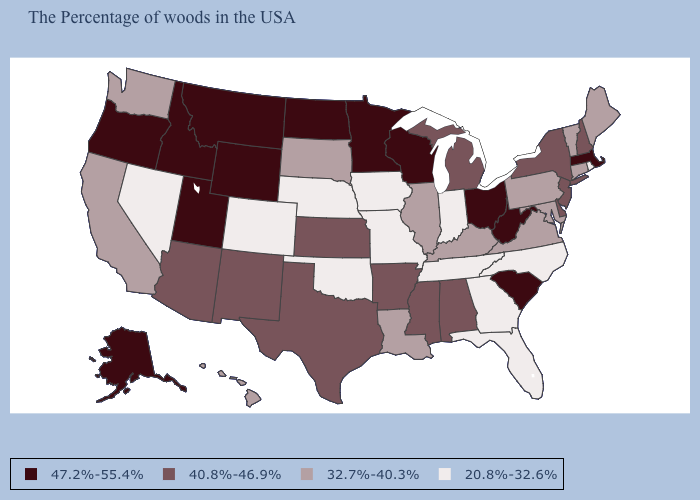Among the states that border Connecticut , does New York have the highest value?
Answer briefly. No. What is the lowest value in the West?
Answer briefly. 20.8%-32.6%. What is the value of Oregon?
Write a very short answer. 47.2%-55.4%. Among the states that border Virginia , which have the lowest value?
Be succinct. North Carolina, Tennessee. What is the lowest value in states that border Georgia?
Answer briefly. 20.8%-32.6%. Which states have the highest value in the USA?
Quick response, please. Massachusetts, South Carolina, West Virginia, Ohio, Wisconsin, Minnesota, North Dakota, Wyoming, Utah, Montana, Idaho, Oregon, Alaska. What is the value of Connecticut?
Give a very brief answer. 32.7%-40.3%. What is the value of Texas?
Quick response, please. 40.8%-46.9%. Does California have the highest value in the USA?
Give a very brief answer. No. Which states have the lowest value in the USA?
Answer briefly. Rhode Island, North Carolina, Florida, Georgia, Indiana, Tennessee, Missouri, Iowa, Nebraska, Oklahoma, Colorado, Nevada. Name the states that have a value in the range 40.8%-46.9%?
Give a very brief answer. New Hampshire, New York, New Jersey, Delaware, Michigan, Alabama, Mississippi, Arkansas, Kansas, Texas, New Mexico, Arizona. What is the value of Massachusetts?
Answer briefly. 47.2%-55.4%. Among the states that border New Mexico , which have the lowest value?
Answer briefly. Oklahoma, Colorado. How many symbols are there in the legend?
Concise answer only. 4. 